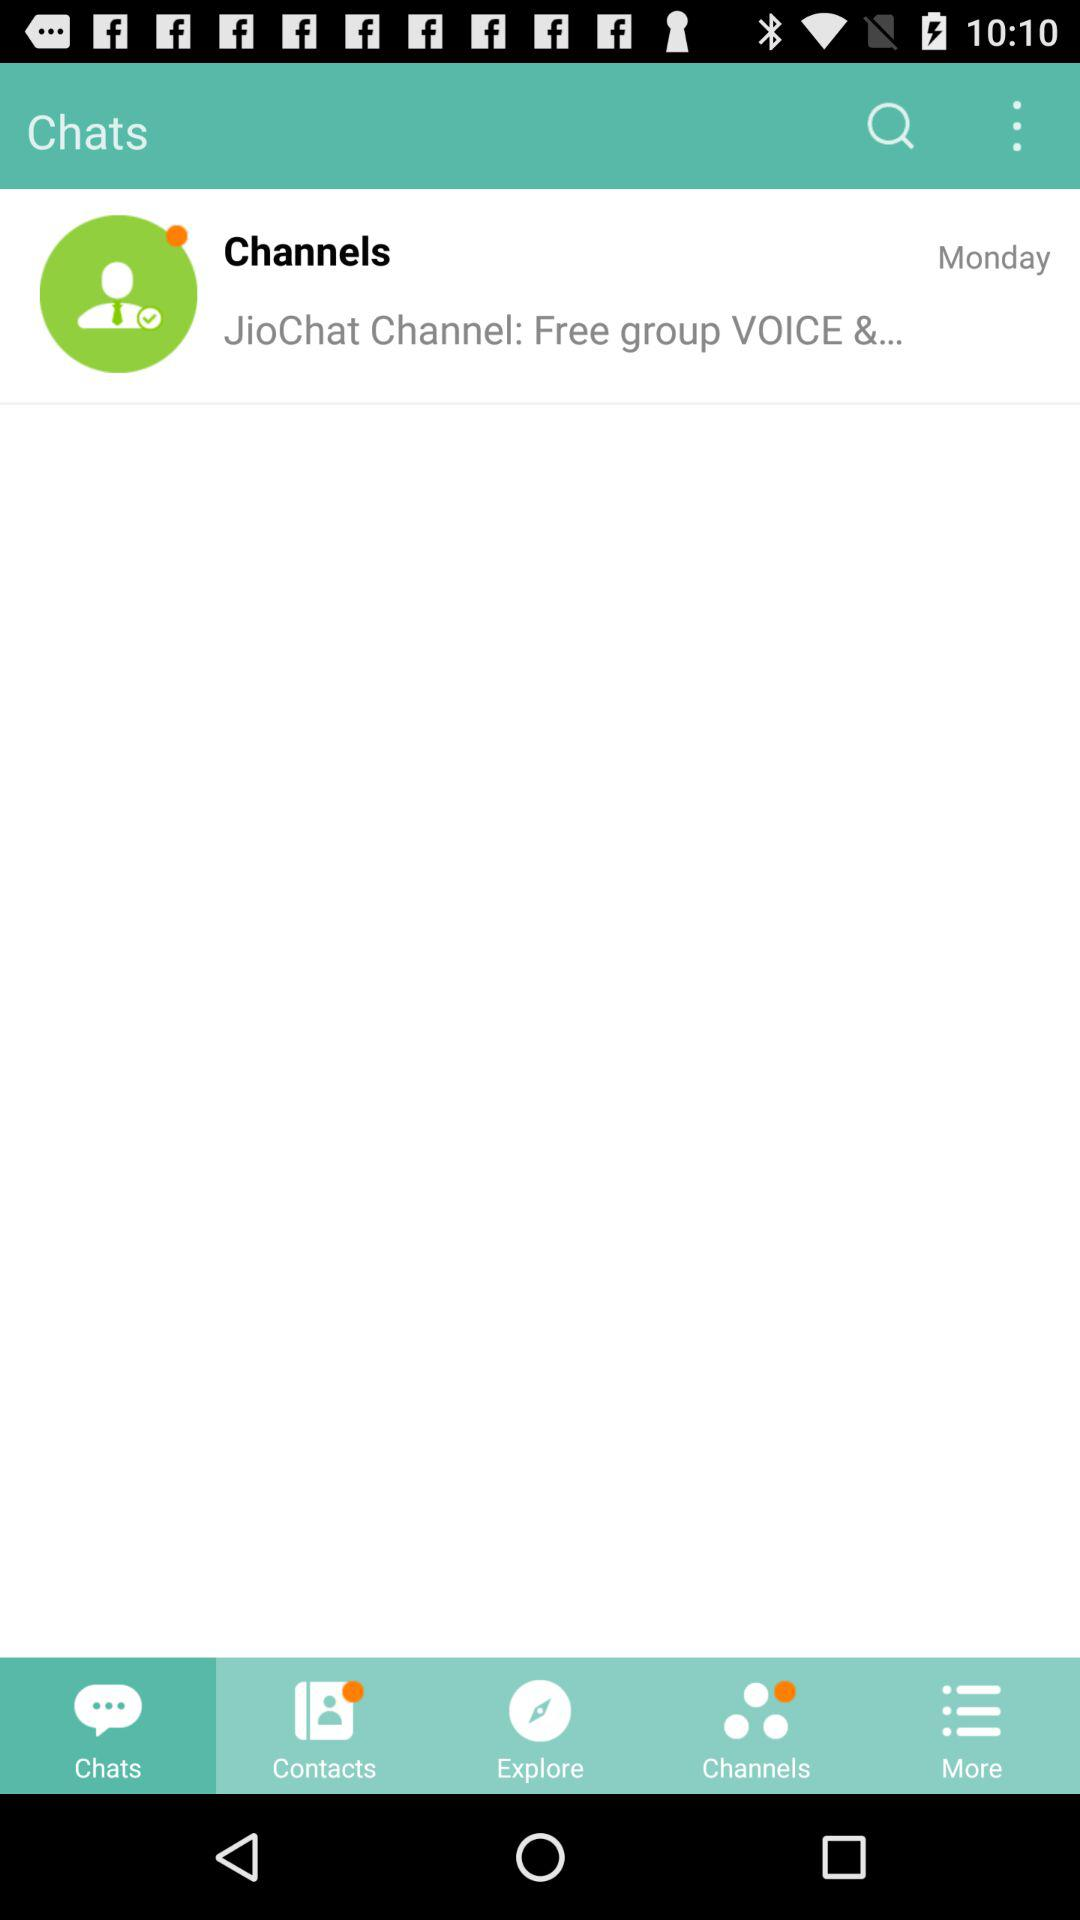What day is shown on the screen? The day is Monday. 